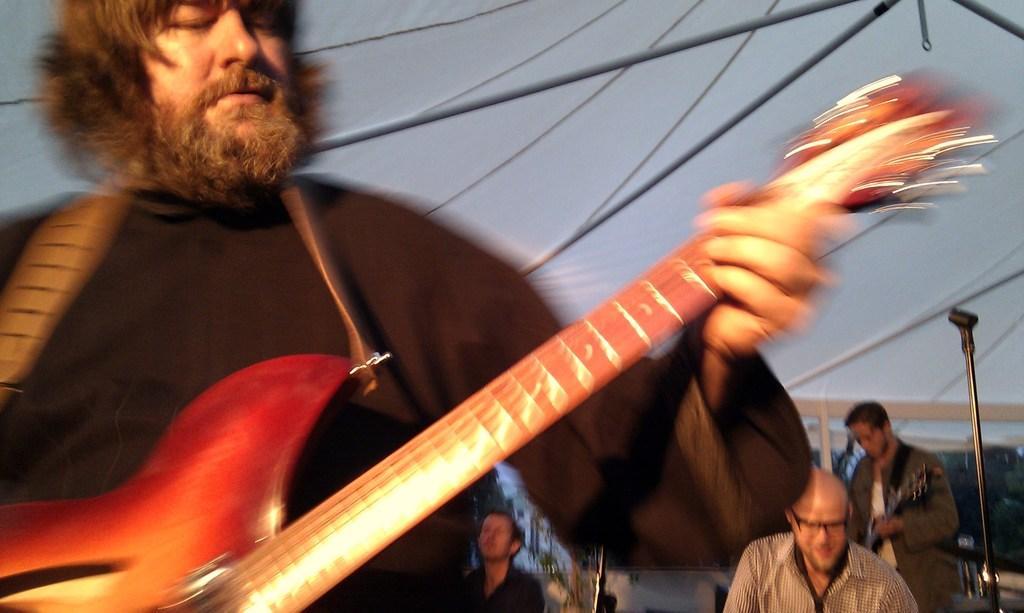Please provide a concise description of this image. One person wearing a black dress is holding guitar and playing it. It is looking like a tent. some persons are behind him and playing instruments. And one mic stand is over there. 